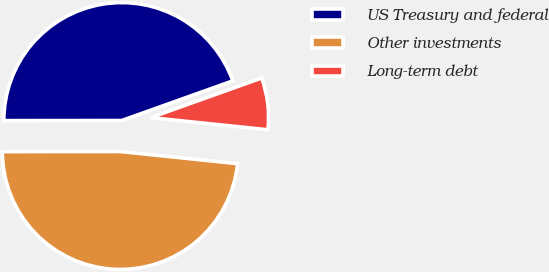<chart> <loc_0><loc_0><loc_500><loc_500><pie_chart><fcel>US Treasury and federal<fcel>Other investments<fcel>Long-term debt<nl><fcel>44.56%<fcel>48.34%<fcel>7.1%<nl></chart> 